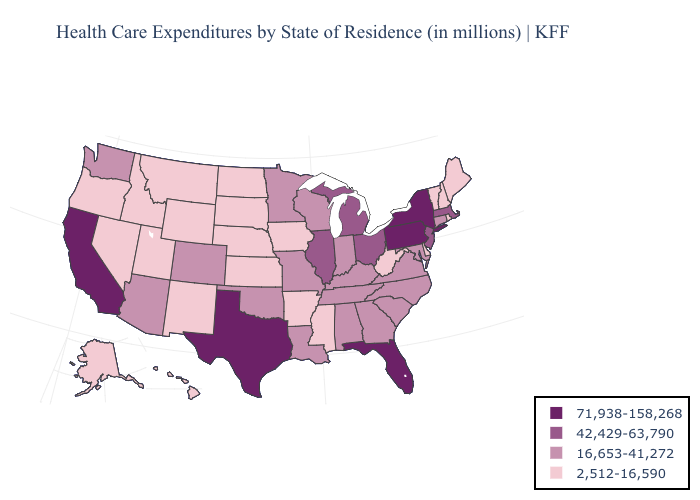What is the lowest value in states that border Texas?
Answer briefly. 2,512-16,590. Among the states that border Maine , which have the highest value?
Give a very brief answer. New Hampshire. Name the states that have a value in the range 42,429-63,790?
Quick response, please. Illinois, Massachusetts, Michigan, New Jersey, Ohio. What is the highest value in states that border Kansas?
Give a very brief answer. 16,653-41,272. Does Iowa have a lower value than Idaho?
Answer briefly. No. What is the value of Missouri?
Quick response, please. 16,653-41,272. Name the states that have a value in the range 42,429-63,790?
Keep it brief. Illinois, Massachusetts, Michigan, New Jersey, Ohio. What is the value of Nevada?
Answer briefly. 2,512-16,590. Does Minnesota have the highest value in the USA?
Short answer required. No. What is the highest value in the USA?
Concise answer only. 71,938-158,268. What is the value of Nevada?
Quick response, please. 2,512-16,590. Does the map have missing data?
Short answer required. No. What is the lowest value in the West?
Quick response, please. 2,512-16,590. Which states have the lowest value in the USA?
Short answer required. Alaska, Arkansas, Delaware, Hawaii, Idaho, Iowa, Kansas, Maine, Mississippi, Montana, Nebraska, Nevada, New Hampshire, New Mexico, North Dakota, Oregon, Rhode Island, South Dakota, Utah, Vermont, West Virginia, Wyoming. Which states have the lowest value in the West?
Concise answer only. Alaska, Hawaii, Idaho, Montana, Nevada, New Mexico, Oregon, Utah, Wyoming. 